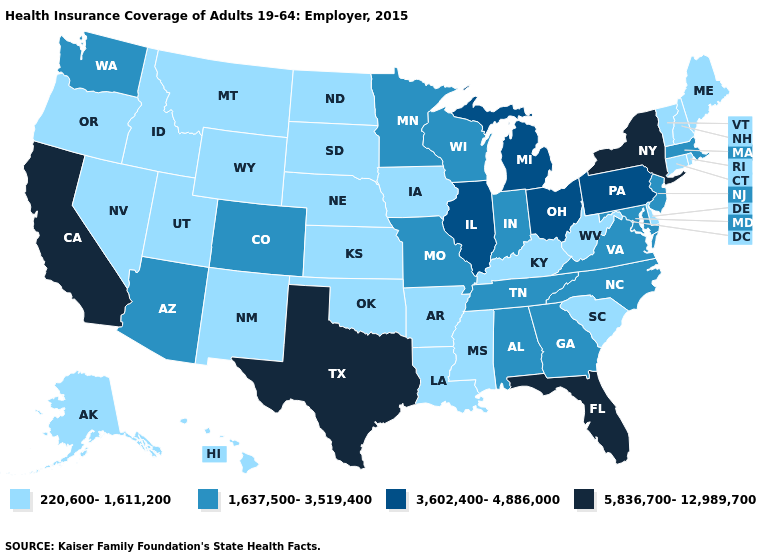Name the states that have a value in the range 5,836,700-12,989,700?
Quick response, please. California, Florida, New York, Texas. Does Indiana have the lowest value in the MidWest?
Keep it brief. No. Name the states that have a value in the range 1,637,500-3,519,400?
Write a very short answer. Alabama, Arizona, Colorado, Georgia, Indiana, Maryland, Massachusetts, Minnesota, Missouri, New Jersey, North Carolina, Tennessee, Virginia, Washington, Wisconsin. What is the highest value in states that border Louisiana?
Quick response, please. 5,836,700-12,989,700. Name the states that have a value in the range 5,836,700-12,989,700?
Give a very brief answer. California, Florida, New York, Texas. Name the states that have a value in the range 220,600-1,611,200?
Write a very short answer. Alaska, Arkansas, Connecticut, Delaware, Hawaii, Idaho, Iowa, Kansas, Kentucky, Louisiana, Maine, Mississippi, Montana, Nebraska, Nevada, New Hampshire, New Mexico, North Dakota, Oklahoma, Oregon, Rhode Island, South Carolina, South Dakota, Utah, Vermont, West Virginia, Wyoming. Name the states that have a value in the range 220,600-1,611,200?
Write a very short answer. Alaska, Arkansas, Connecticut, Delaware, Hawaii, Idaho, Iowa, Kansas, Kentucky, Louisiana, Maine, Mississippi, Montana, Nebraska, Nevada, New Hampshire, New Mexico, North Dakota, Oklahoma, Oregon, Rhode Island, South Carolina, South Dakota, Utah, Vermont, West Virginia, Wyoming. Among the states that border Louisiana , which have the lowest value?
Keep it brief. Arkansas, Mississippi. Does Florida have the highest value in the USA?
Answer briefly. Yes. Which states hav the highest value in the South?
Be succinct. Florida, Texas. Does New Mexico have a higher value than New York?
Keep it brief. No. What is the highest value in the USA?
Write a very short answer. 5,836,700-12,989,700. What is the highest value in states that border North Dakota?
Short answer required. 1,637,500-3,519,400. Does Tennessee have the same value as Pennsylvania?
Concise answer only. No. Does Arizona have the same value as Colorado?
Write a very short answer. Yes. 